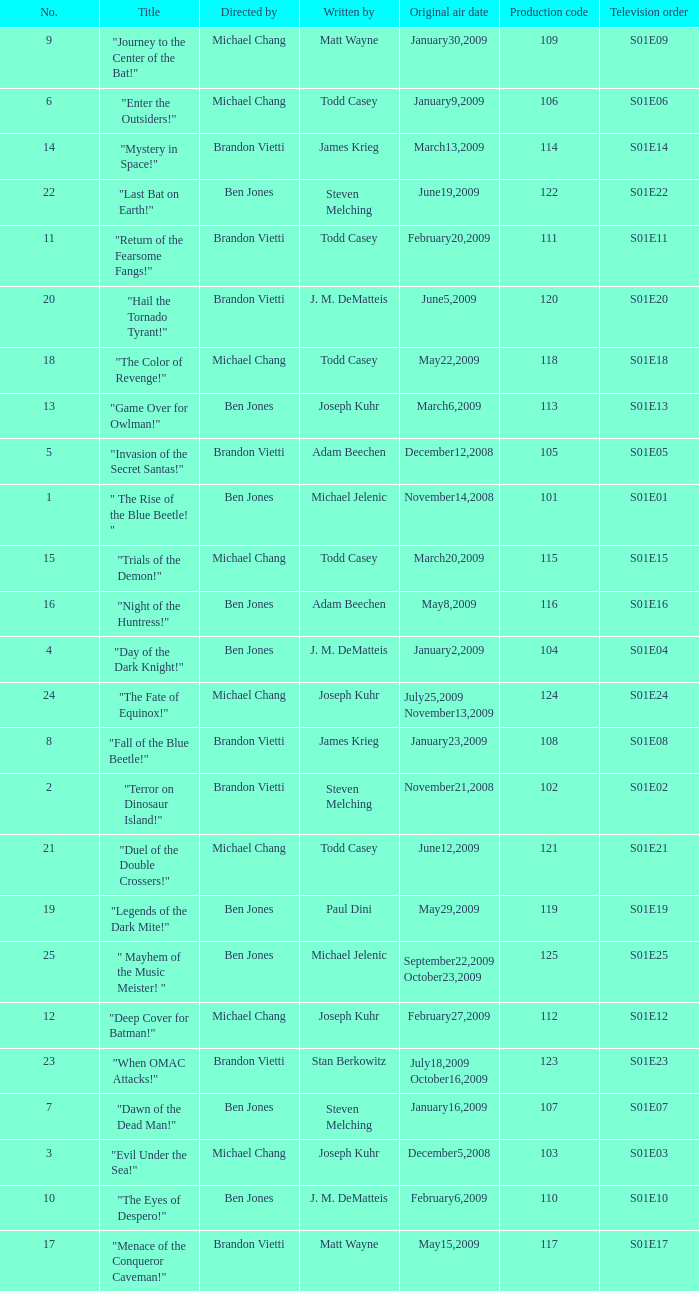Who directed s01e13 Ben Jones. 